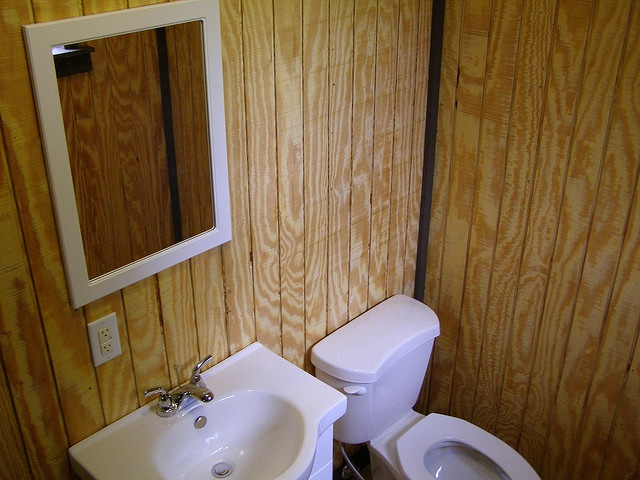Describe the objects in this image and their specific colors. I can see sink in maroon, darkgray, lavender, and gray tones and toilet in maroon, darkgray, lavender, and gray tones in this image. 